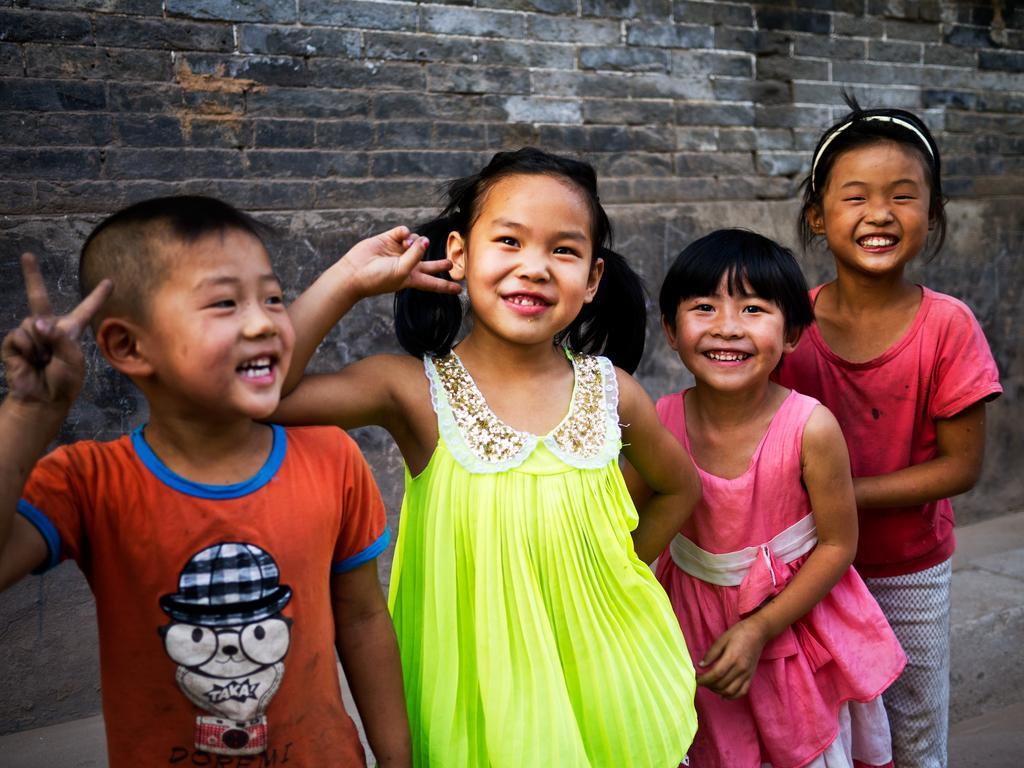Could you give a brief overview of what you see in this image? In this image we can see some children standing. on the backside we can see a wall with bricks. 